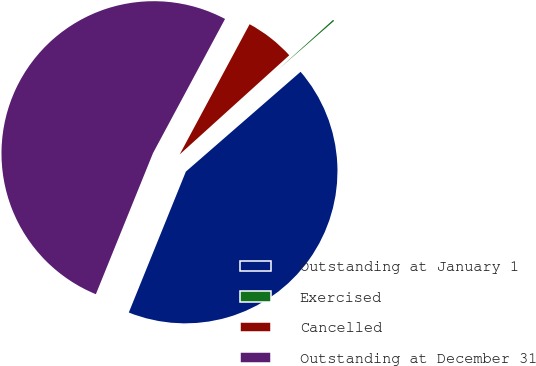Convert chart. <chart><loc_0><loc_0><loc_500><loc_500><pie_chart><fcel>Outstanding at January 1<fcel>Exercised<fcel>Cancelled<fcel>Outstanding at December 31<nl><fcel>42.52%<fcel>0.31%<fcel>5.45%<fcel>51.72%<nl></chart> 